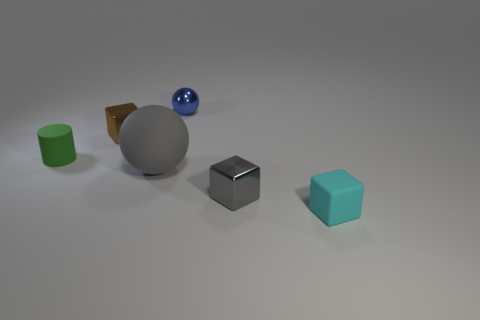Add 1 tiny metal blocks. How many objects exist? 7 Subtract all spheres. How many objects are left? 4 Add 1 small blue balls. How many small blue balls exist? 2 Subtract 1 blue balls. How many objects are left? 5 Subtract all small red rubber things. Subtract all small gray metal cubes. How many objects are left? 5 Add 5 blue metal objects. How many blue metal objects are left? 6 